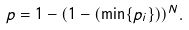<formula> <loc_0><loc_0><loc_500><loc_500>p = 1 - ( 1 - ( \min \{ p _ { i } \} ) ) ^ { N } .</formula> 